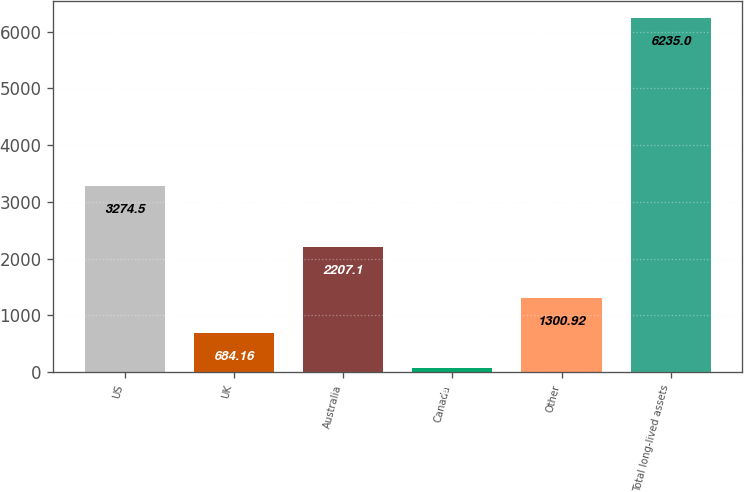<chart> <loc_0><loc_0><loc_500><loc_500><bar_chart><fcel>US<fcel>UK<fcel>Australia<fcel>Canada<fcel>Other<fcel>Total long-lived assets<nl><fcel>3274.5<fcel>684.16<fcel>2207.1<fcel>67.4<fcel>1300.92<fcel>6235<nl></chart> 